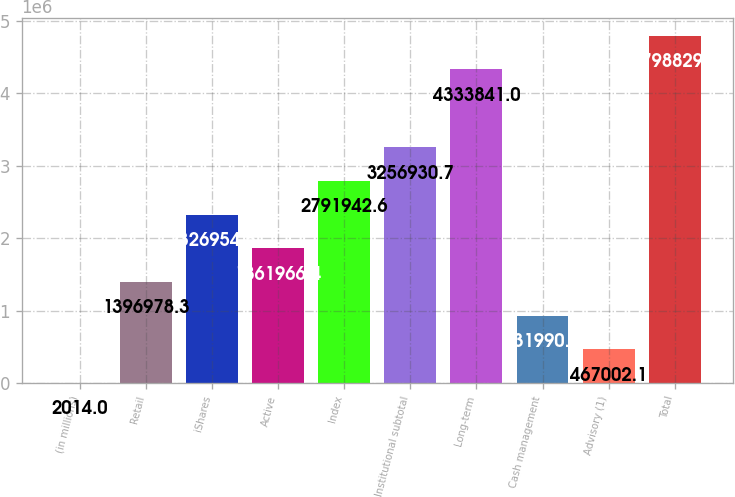<chart> <loc_0><loc_0><loc_500><loc_500><bar_chart><fcel>(in millions)<fcel>Retail<fcel>iShares<fcel>Active<fcel>Index<fcel>Institutional subtotal<fcel>Long-term<fcel>Cash management<fcel>Advisory (1)<fcel>Total<nl><fcel>2014<fcel>1.39698e+06<fcel>2.32695e+06<fcel>1.86197e+06<fcel>2.79194e+06<fcel>3.25693e+06<fcel>4.33384e+06<fcel>931990<fcel>467002<fcel>4.79883e+06<nl></chart> 